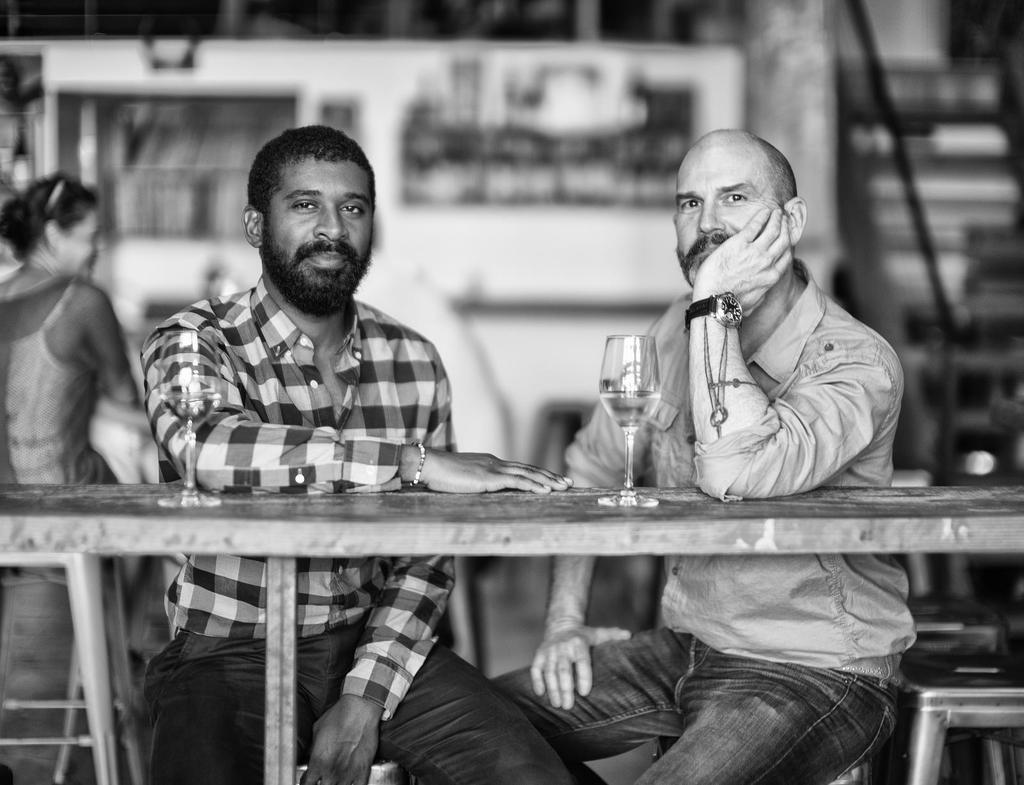How many people are in the image? There are two men in the image. What are the men doing in the image? The men are sitting on chairs. What can be seen on the table in the image? There is a glass with a drink on the table. Where is the woman located in the image? The woman is standing on the left side of the image. What type of poison is the woman holding in the image? There is no poison present in the image; the woman is not holding anything. 